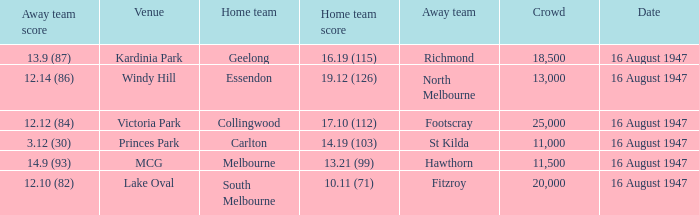How much did the away team score at victoria park? 12.12 (84). 